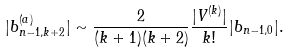<formula> <loc_0><loc_0><loc_500><loc_500>| b _ { n - 1 , k + 2 } ^ { ( a ) } | \sim \frac { 2 } { ( k + 1 ) ( k + 2 ) } \frac { | V ^ { ( k ) } | } { k ! } | b _ { n - 1 , 0 } | .</formula> 